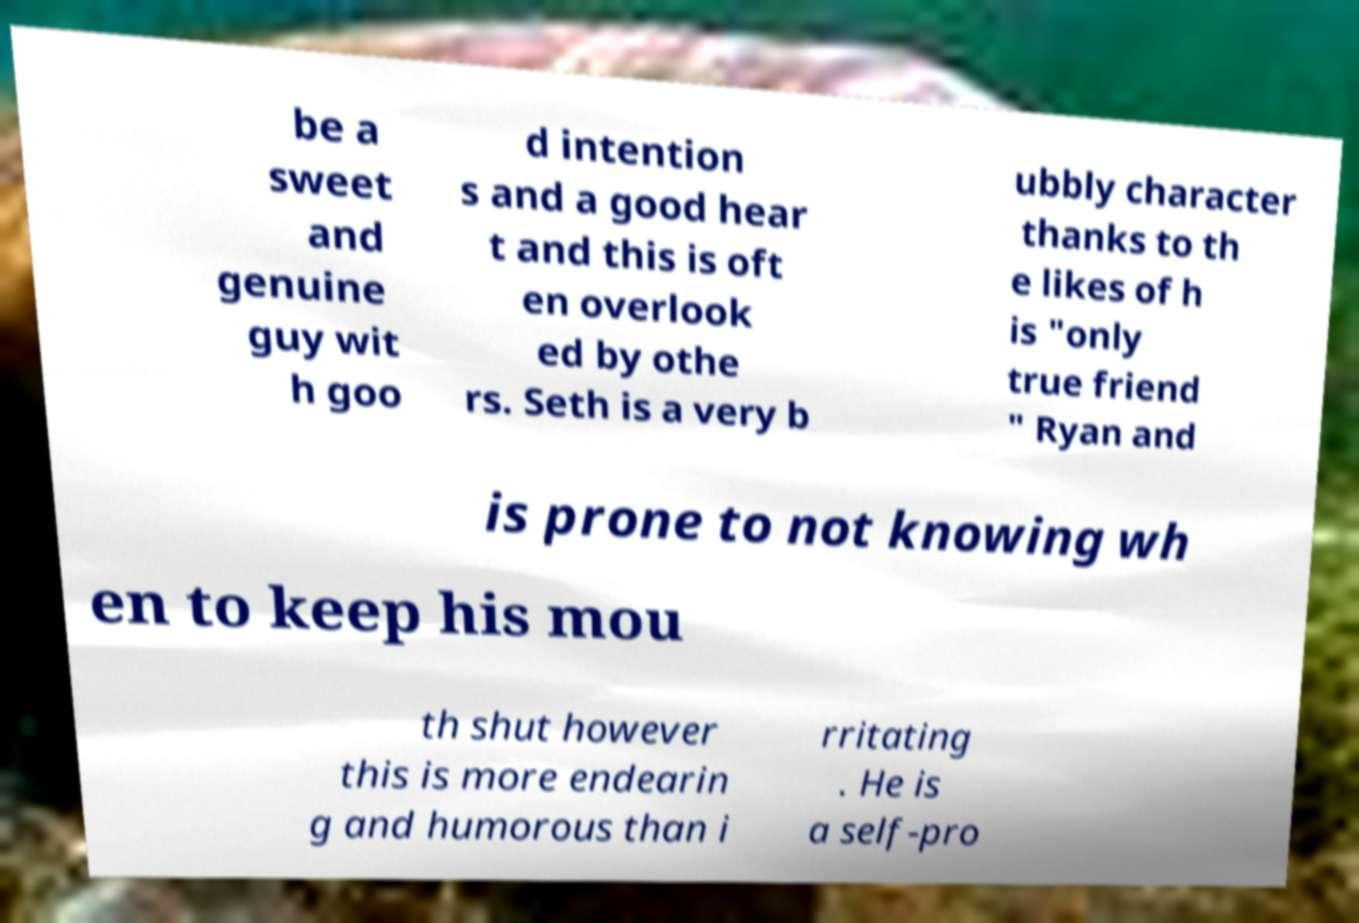Please identify and transcribe the text found in this image. be a sweet and genuine guy wit h goo d intention s and a good hear t and this is oft en overlook ed by othe rs. Seth is a very b ubbly character thanks to th e likes of h is "only true friend " Ryan and is prone to not knowing wh en to keep his mou th shut however this is more endearin g and humorous than i rritating . He is a self-pro 